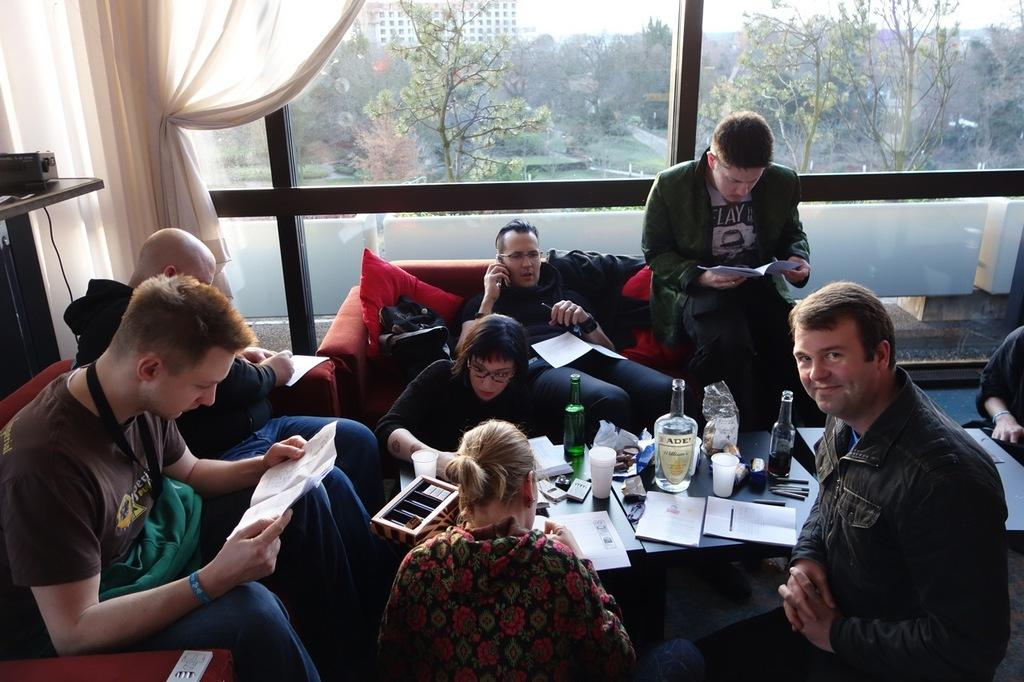What are the people in the image doing? The people in the image are sitting. What objects can be seen on the table in the image? There are bottles, a paper, a cup, and a box on the table in the image. What is visible outside the window in the image? Buildings, trees, and grass are visible outside the window in the image. What type of pig can be seen going on a journey in the image? There is no pig or journey present in the image. What is located at the front of the table in the image? The provided facts do not specify any objects being at the front of the table, so we cannot answer this question definitively. 